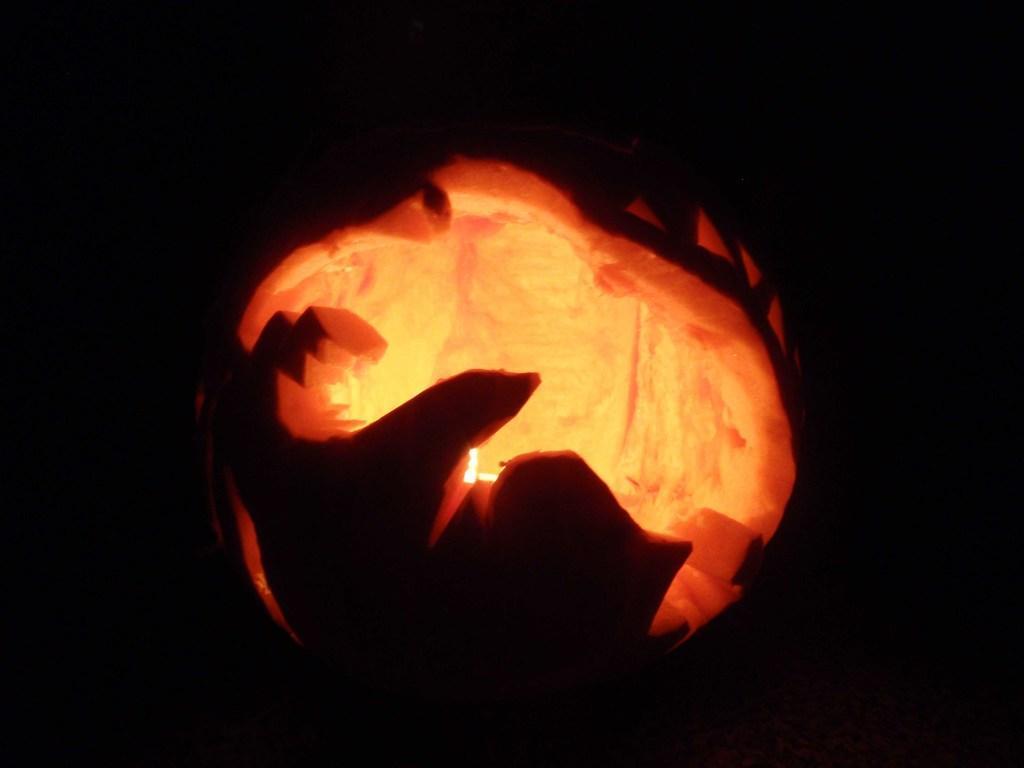In one or two sentences, can you explain what this image depicts? In the middle of the picture, we see a carved pumpkin. It is black in the background and this picture might be clicked in the dark. 